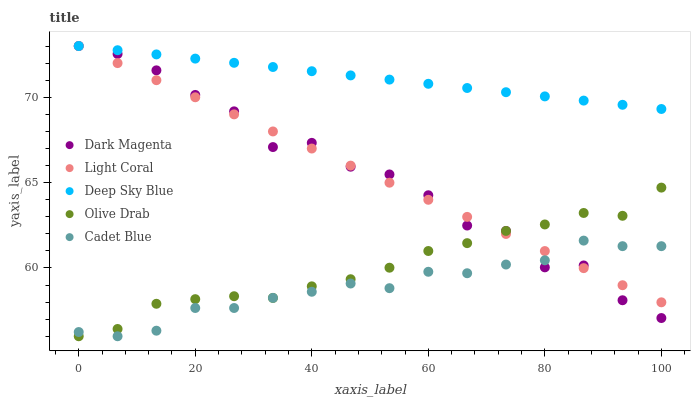Does Cadet Blue have the minimum area under the curve?
Answer yes or no. Yes. Does Deep Sky Blue have the maximum area under the curve?
Answer yes or no. Yes. Does Olive Drab have the minimum area under the curve?
Answer yes or no. No. Does Olive Drab have the maximum area under the curve?
Answer yes or no. No. Is Deep Sky Blue the smoothest?
Answer yes or no. Yes. Is Dark Magenta the roughest?
Answer yes or no. Yes. Is Olive Drab the smoothest?
Answer yes or no. No. Is Olive Drab the roughest?
Answer yes or no. No. Does Olive Drab have the lowest value?
Answer yes or no. Yes. Does Dark Magenta have the lowest value?
Answer yes or no. No. Does Deep Sky Blue have the highest value?
Answer yes or no. Yes. Does Olive Drab have the highest value?
Answer yes or no. No. Is Cadet Blue less than Deep Sky Blue?
Answer yes or no. Yes. Is Deep Sky Blue greater than Olive Drab?
Answer yes or no. Yes. Does Dark Magenta intersect Olive Drab?
Answer yes or no. Yes. Is Dark Magenta less than Olive Drab?
Answer yes or no. No. Is Dark Magenta greater than Olive Drab?
Answer yes or no. No. Does Cadet Blue intersect Deep Sky Blue?
Answer yes or no. No. 